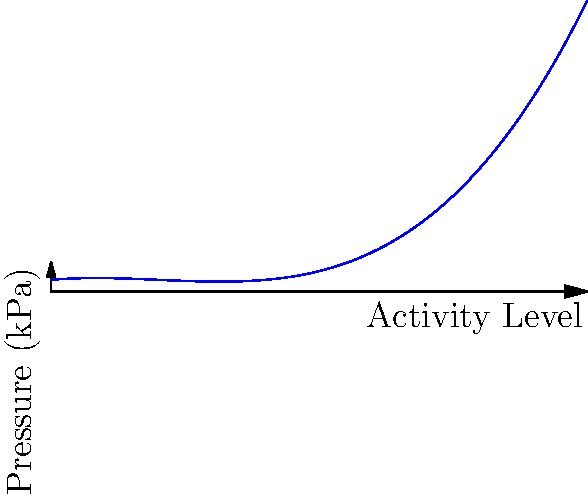The graph shows the pressure distribution curve on a prosthetic socket during different activities. If the pressure (in kPa) is modeled by the function $P(x) = 0.5x^3 - 3x^2 + 4x + 10$, where $x$ represents the activity level from 0 to 10, at what activity level does the prosthetic socket experience the minimum pressure? To find the activity level where the prosthetic socket experiences the minimum pressure, we need to follow these steps:

1) The minimum point of the function occurs where its derivative equals zero. So, we need to find $P'(x)$ and set it to zero.

2) $P(x) = 0.5x^3 - 3x^2 + 4x + 10$
   $P'(x) = 1.5x^2 - 6x + 4$

3) Set $P'(x) = 0$:
   $1.5x^2 - 6x + 4 = 0$

4) This is a quadratic equation. We can solve it using the quadratic formula:
   $x = \frac{-b \pm \sqrt{b^2 - 4ac}}{2a}$

   Where $a = 1.5$, $b = -6$, and $c = 4$

5) Plugging these values into the quadratic formula:
   $x = \frac{6 \pm \sqrt{36 - 24}}{3} = \frac{6 \pm \sqrt{12}}{3} = \frac{6 \pm 2\sqrt{3}}{3}$

6) This gives us two solutions:
   $x_1 = \frac{6 + 2\sqrt{3}}{3} = 2 + \frac{2\sqrt{3}}{3} \approx 3.15$
   $x_2 = \frac{6 - 2\sqrt{3}}{3} = 2 - \frac{2\sqrt{3}}{3} \approx 0.85$

7) To determine which of these gives the minimum (rather than maximum) pressure, we can check the second derivative:
   $P''(x) = 3x - 6$

   At $x_1 \approx 3.15$: $P''(3.15) > 0$, indicating a minimum
   At $x_2 \approx 0.85$: $P''(0.85) < 0$, indicating a maximum

Therefore, the minimum pressure occurs at an activity level of approximately 3.15.
Answer: 3.15 